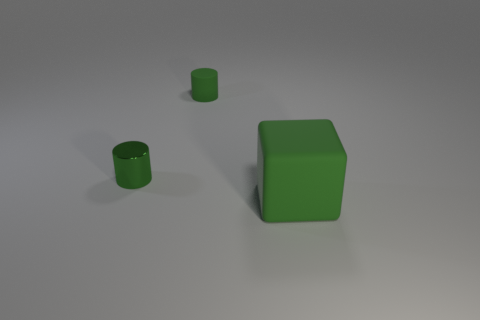Is the block made of the same material as the object behind the green shiny cylinder?
Your response must be concise. Yes. What is the shape of the object that is to the left of the large green thing and on the right side of the metal object?
Offer a very short reply. Cylinder. How many other objects are there of the same color as the tiny metallic object?
Your answer should be compact. 2. There is a small green metallic thing; what shape is it?
Your response must be concise. Cylinder. There is a rubber thing that is to the right of the green matte object that is to the left of the large green matte block; what is its color?
Keep it short and to the point. Green. Is the color of the big thing the same as the rubber object that is to the left of the large green matte cube?
Ensure brevity in your answer.  Yes. There is a object that is behind the big green object and on the right side of the tiny green metal cylinder; what material is it made of?
Make the answer very short. Rubber. Are there any rubber cubes of the same size as the green metal object?
Make the answer very short. No. There is a object that is the same size as the green rubber cylinder; what material is it?
Offer a terse response. Metal. What number of green shiny cylinders are to the left of the shiny object?
Ensure brevity in your answer.  0. 